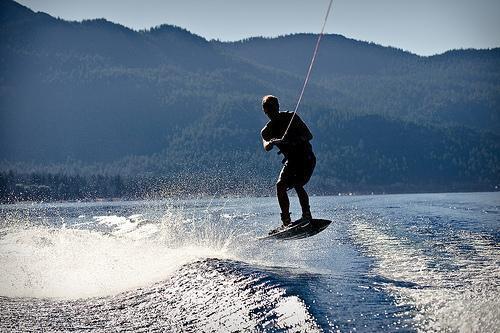How many people in the photo?
Give a very brief answer. 1. 